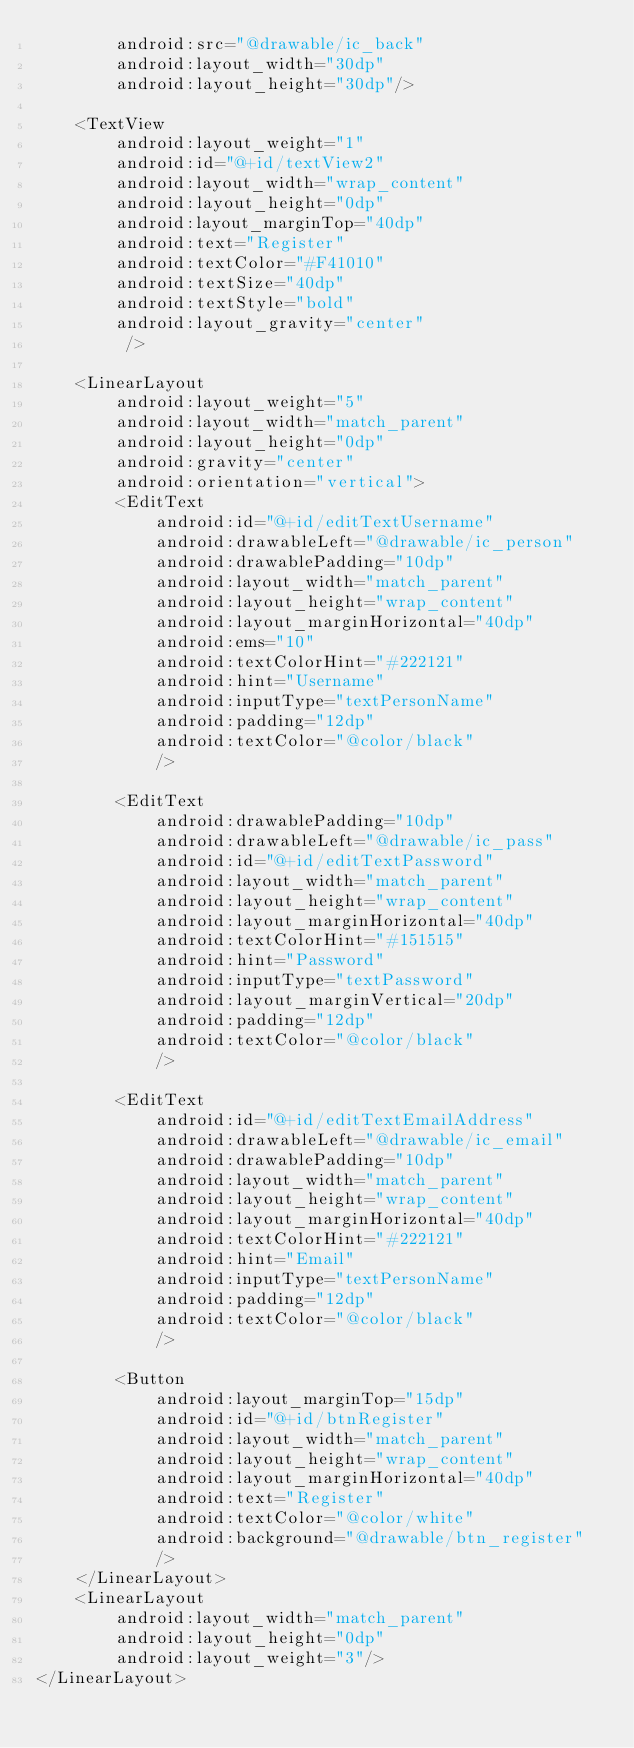<code> <loc_0><loc_0><loc_500><loc_500><_XML_>        android:src="@drawable/ic_back"
        android:layout_width="30dp"
        android:layout_height="30dp"/>

    <TextView
        android:layout_weight="1"
        android:id="@+id/textView2"
        android:layout_width="wrap_content"
        android:layout_height="0dp"
        android:layout_marginTop="40dp"
        android:text="Register"
        android:textColor="#F41010"
        android:textSize="40dp"
        android:textStyle="bold"
        android:layout_gravity="center"
         />

    <LinearLayout
        android:layout_weight="5"
        android:layout_width="match_parent"
        android:layout_height="0dp"
        android:gravity="center"
        android:orientation="vertical">
        <EditText
            android:id="@+id/editTextUsername"
            android:drawableLeft="@drawable/ic_person"
            android:drawablePadding="10dp"
            android:layout_width="match_parent"
            android:layout_height="wrap_content"
            android:layout_marginHorizontal="40dp"
            android:ems="10"
            android:textColorHint="#222121"
            android:hint="Username"
            android:inputType="textPersonName"
            android:padding="12dp"
            android:textColor="@color/black"
            />

        <EditText
            android:drawablePadding="10dp"
            android:drawableLeft="@drawable/ic_pass"
            android:id="@+id/editTextPassword"
            android:layout_width="match_parent"
            android:layout_height="wrap_content"
            android:layout_marginHorizontal="40dp"
            android:textColorHint="#151515"
            android:hint="Password"
            android:inputType="textPassword"
            android:layout_marginVertical="20dp"
            android:padding="12dp"
            android:textColor="@color/black"
            />

        <EditText
            android:id="@+id/editTextEmailAddress"
            android:drawableLeft="@drawable/ic_email"
            android:drawablePadding="10dp"
            android:layout_width="match_parent"
            android:layout_height="wrap_content"
            android:layout_marginHorizontal="40dp"
            android:textColorHint="#222121"
            android:hint="Email"
            android:inputType="textPersonName"
            android:padding="12dp"
            android:textColor="@color/black"
            />

        <Button
            android:layout_marginTop="15dp"
            android:id="@+id/btnRegister"
            android:layout_width="match_parent"
            android:layout_height="wrap_content"
            android:layout_marginHorizontal="40dp"
            android:text="Register"
            android:textColor="@color/white"
            android:background="@drawable/btn_register"
            />
    </LinearLayout>
    <LinearLayout
        android:layout_width="match_parent"
        android:layout_height="0dp"
        android:layout_weight="3"/>
</LinearLayout></code> 